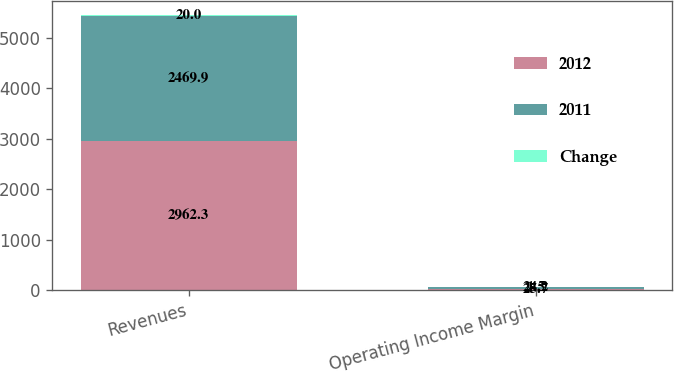<chart> <loc_0><loc_0><loc_500><loc_500><stacked_bar_chart><ecel><fcel>Revenues<fcel>Operating Income Margin<nl><fcel>2012<fcel>2962.3<fcel>25.7<nl><fcel>2011<fcel>2469.9<fcel>24.2<nl><fcel>Change<fcel>20<fcel>1.5<nl></chart> 